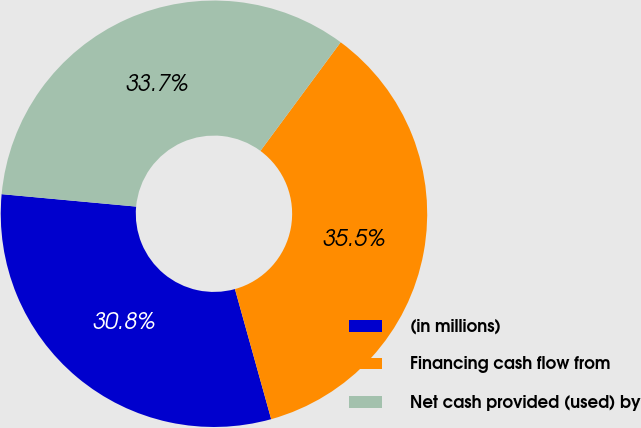Convert chart. <chart><loc_0><loc_0><loc_500><loc_500><pie_chart><fcel>(in millions)<fcel>Financing cash flow from<fcel>Net cash provided (used) by<nl><fcel>30.79%<fcel>35.55%<fcel>33.66%<nl></chart> 